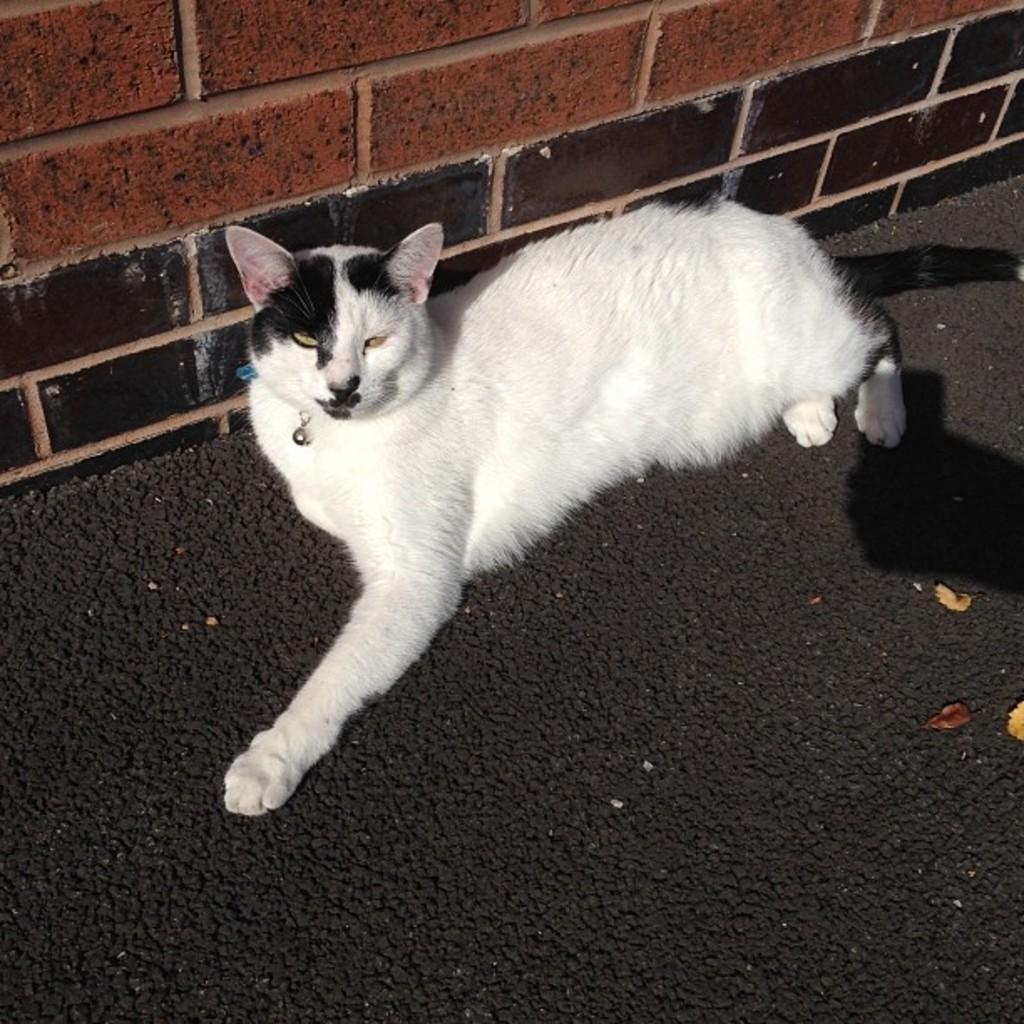What type of animal is in the image? There is a cat in the image. What is located beside the cat? There is a brick wall beside the cat. What type of car can be seen driving past the cat in the image? There is no car present in the image; it only features a cat and a brick wall. How many monkeys are visible interacting with the cat in the image? There are no monkeys present in the image; it only features a cat and a brick wall. 